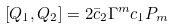<formula> <loc_0><loc_0><loc_500><loc_500>[ Q _ { 1 } , Q _ { 2 } ] = 2 \bar { c } _ { 2 } \Gamma ^ { m } c _ { 1 } P _ { m }</formula> 